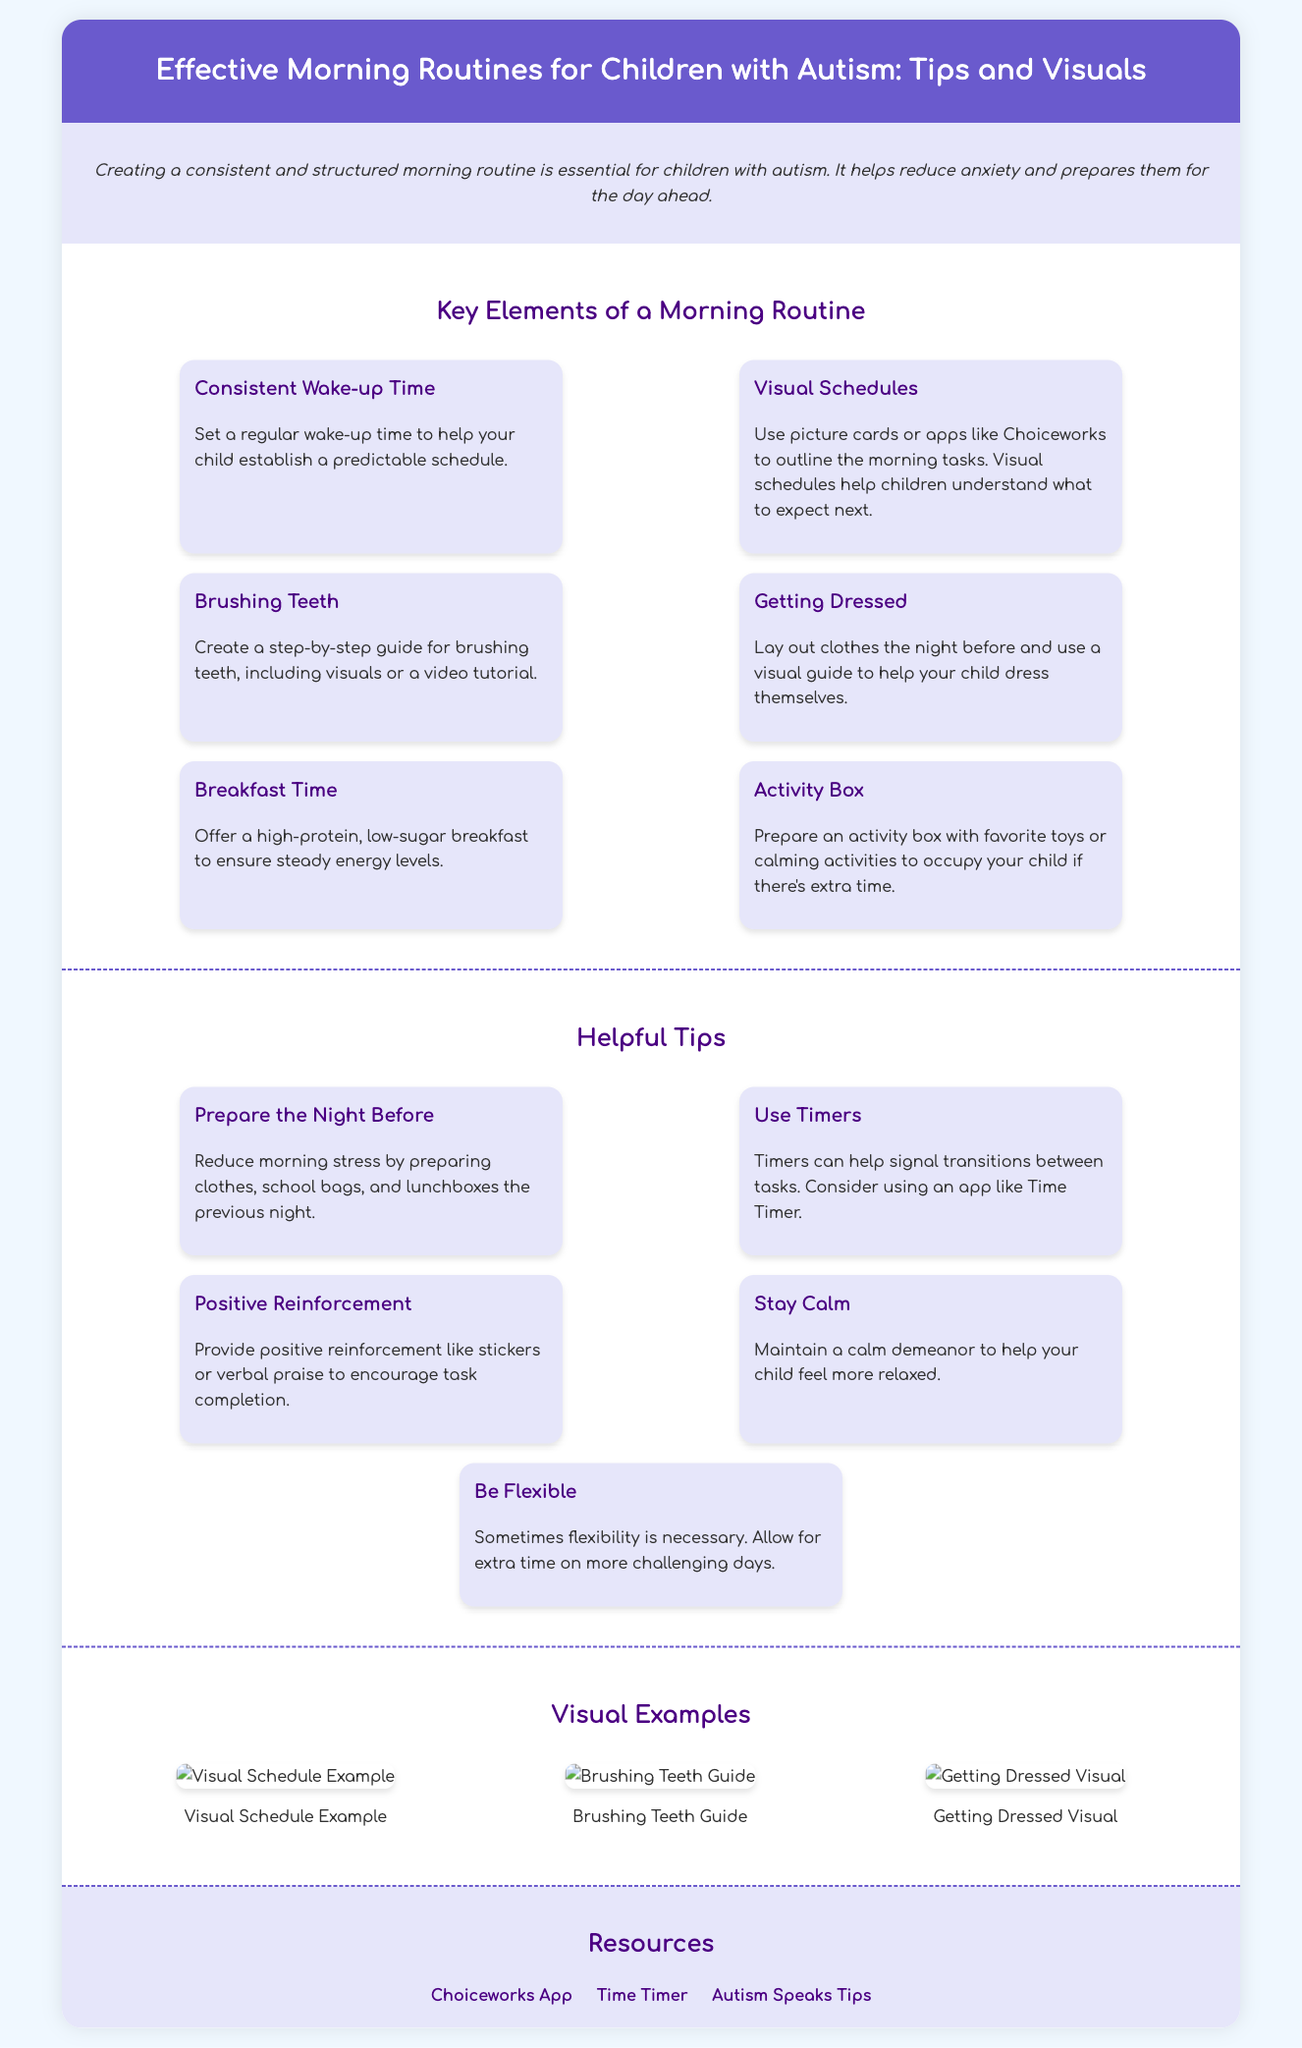What is the title of the infographic? The title of the infographic is prominently displayed at the top and reads "Effective Morning Routines for Children with Autism: Tips and Visuals."
Answer: Effective Morning Routines for Children with Autism: Tips and Visuals How many key elements are listed in the morning routine section? The morning routine section lists six key elements for creating an effective routine for children with autism.
Answer: Six What color is used for the background of the header? The header background color is specifically noted in the document and is a shade of blue.
Answer: #6a5acd Which app is recommended for visual schedules? The document mentions an app named Choiceworks, which is recommended for creating visual schedules.
Answer: Choiceworks What should be offered for breakfast according to the tips? The document advises offering a high-protein, low-sugar breakfast to manage energy levels effectively.
Answer: High-protein, low-sugar What is the recommended strategy for managing transitions between tasks? The infographic suggests using timers as a strategy for helping manage transitions.
Answer: Timers How can parents prepare to reduce morning stress? Parents can prepare by getting clothes, school bags, and lunchboxes ready the night before to lessen stress.
Answer: Prepare the Night Before What visual examples are provided in the document? The document lists three visual examples, including a visual schedule example and guides for brushing teeth and getting dressed.
Answer: Visual Schedule Example, Brushing Teeth Guide, Getting Dressed Visual What is one of the resources linked in the infographic? The document contains resources with links, one of which is Autism Speaks Tips.
Answer: Autism Speaks Tips 